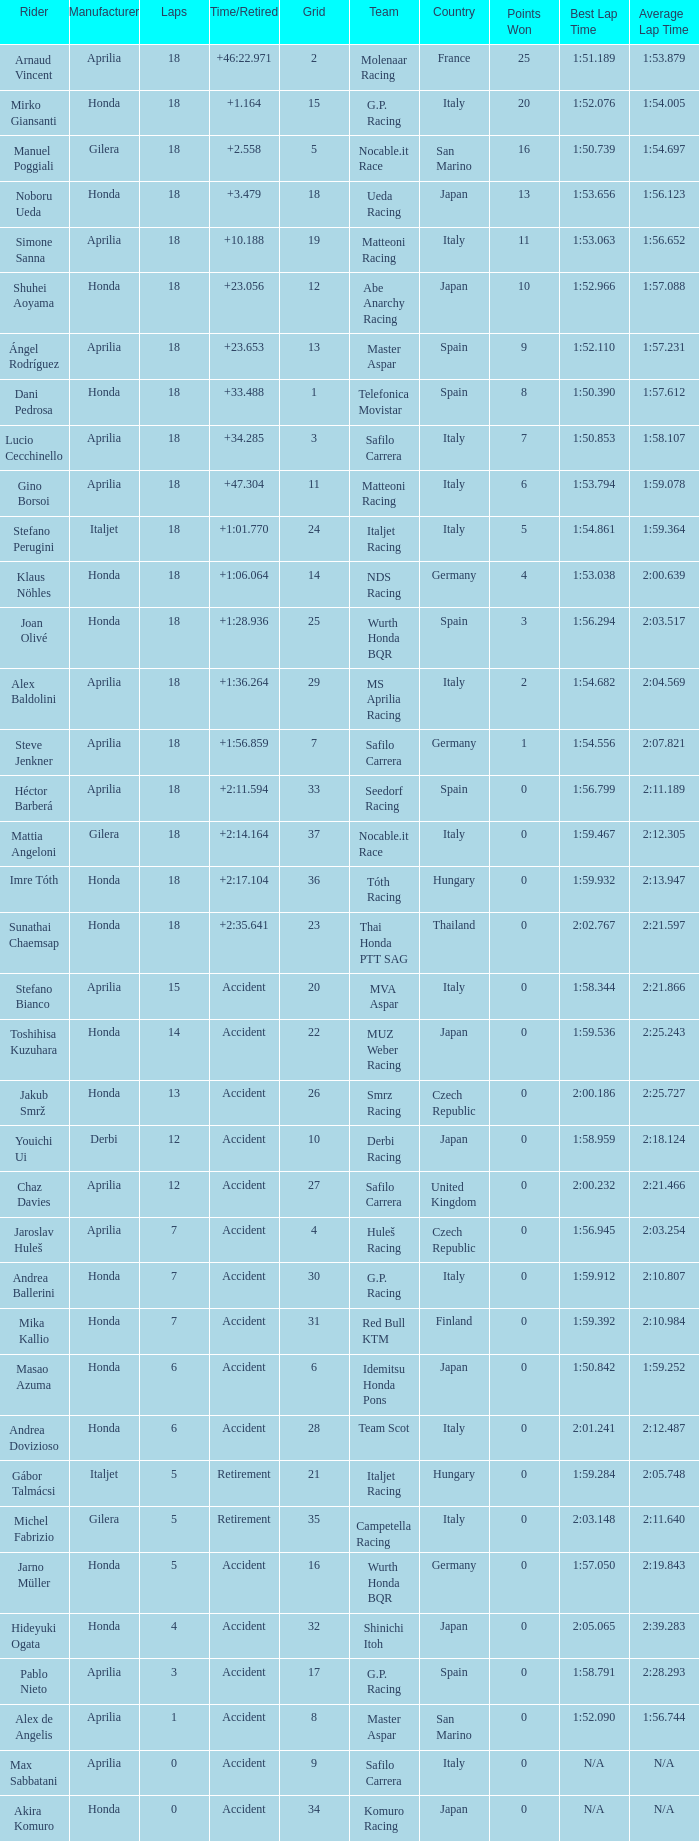What is the time/retired of the honda manufacturer with a grid less than 26, 18 laps, and joan olivé as the rider? +1:28.936. 